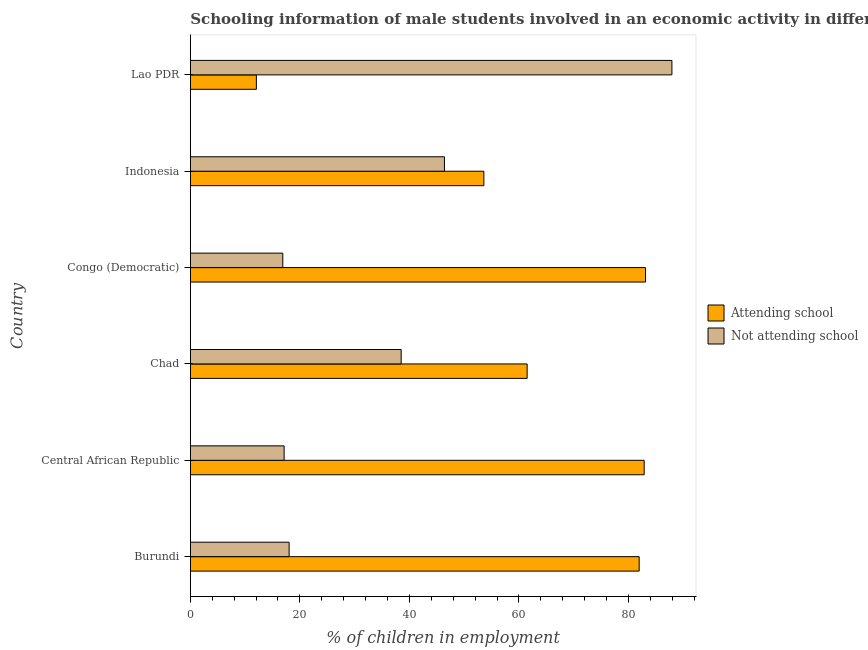How many different coloured bars are there?
Keep it short and to the point. 2. How many groups of bars are there?
Your response must be concise. 6. Are the number of bars per tick equal to the number of legend labels?
Keep it short and to the point. Yes. How many bars are there on the 4th tick from the bottom?
Your answer should be very brief. 2. What is the label of the 6th group of bars from the top?
Make the answer very short. Burundi. What is the percentage of employed males who are not attending school in Congo (Democratic)?
Offer a terse response. 16.89. Across all countries, what is the maximum percentage of employed males who are attending school?
Offer a terse response. 83.11. Across all countries, what is the minimum percentage of employed males who are not attending school?
Ensure brevity in your answer.  16.89. In which country was the percentage of employed males who are attending school maximum?
Your answer should be very brief. Congo (Democratic). In which country was the percentage of employed males who are attending school minimum?
Provide a short and direct response. Lao PDR. What is the total percentage of employed males who are not attending school in the graph?
Your answer should be compact. 224.9. What is the difference between the percentage of employed males who are not attending school in Burundi and that in Lao PDR?
Your answer should be very brief. -69.89. What is the difference between the percentage of employed males who are attending school in Burundi and the percentage of employed males who are not attending school in Indonesia?
Make the answer very short. 35.56. What is the average percentage of employed males who are not attending school per country?
Offer a terse response. 37.48. What is the difference between the percentage of employed males who are attending school and percentage of employed males who are not attending school in Chad?
Your answer should be compact. 23. What is the ratio of the percentage of employed males who are not attending school in Indonesia to that in Lao PDR?
Your response must be concise. 0.53. Is the difference between the percentage of employed males who are not attending school in Burundi and Chad greater than the difference between the percentage of employed males who are attending school in Burundi and Chad?
Your answer should be compact. No. What is the difference between the highest and the second highest percentage of employed males who are not attending school?
Provide a short and direct response. 41.53. What is the difference between the highest and the lowest percentage of employed males who are attending school?
Your answer should be compact. 71.05. In how many countries, is the percentage of employed males who are not attending school greater than the average percentage of employed males who are not attending school taken over all countries?
Give a very brief answer. 3. What does the 1st bar from the top in Burundi represents?
Ensure brevity in your answer.  Not attending school. What does the 2nd bar from the bottom in Burundi represents?
Offer a very short reply. Not attending school. Are all the bars in the graph horizontal?
Offer a terse response. Yes. How many countries are there in the graph?
Give a very brief answer. 6. Are the values on the major ticks of X-axis written in scientific E-notation?
Provide a succinct answer. No. Does the graph contain any zero values?
Ensure brevity in your answer.  No. Does the graph contain grids?
Make the answer very short. No. How are the legend labels stacked?
Provide a short and direct response. Vertical. What is the title of the graph?
Give a very brief answer. Schooling information of male students involved in an economic activity in different countries. What is the label or title of the X-axis?
Your response must be concise. % of children in employment. What is the label or title of the Y-axis?
Ensure brevity in your answer.  Country. What is the % of children in employment in Attending school in Burundi?
Provide a short and direct response. 81.96. What is the % of children in employment of Not attending school in Burundi?
Your answer should be very brief. 18.04. What is the % of children in employment of Attending school in Central African Republic?
Your response must be concise. 82.87. What is the % of children in employment of Not attending school in Central African Republic?
Give a very brief answer. 17.13. What is the % of children in employment of Attending school in Chad?
Keep it short and to the point. 61.5. What is the % of children in employment of Not attending school in Chad?
Your answer should be compact. 38.5. What is the % of children in employment of Attending school in Congo (Democratic)?
Ensure brevity in your answer.  83.11. What is the % of children in employment in Not attending school in Congo (Democratic)?
Ensure brevity in your answer.  16.89. What is the % of children in employment of Attending school in Indonesia?
Give a very brief answer. 53.6. What is the % of children in employment of Not attending school in Indonesia?
Offer a terse response. 46.4. What is the % of children in employment in Attending school in Lao PDR?
Give a very brief answer. 12.07. What is the % of children in employment of Not attending school in Lao PDR?
Provide a succinct answer. 87.93. Across all countries, what is the maximum % of children in employment of Attending school?
Provide a succinct answer. 83.11. Across all countries, what is the maximum % of children in employment in Not attending school?
Give a very brief answer. 87.93. Across all countries, what is the minimum % of children in employment in Attending school?
Your response must be concise. 12.07. Across all countries, what is the minimum % of children in employment in Not attending school?
Provide a succinct answer. 16.89. What is the total % of children in employment in Attending school in the graph?
Offer a terse response. 375.1. What is the total % of children in employment of Not attending school in the graph?
Offer a terse response. 224.9. What is the difference between the % of children in employment of Attending school in Burundi and that in Central African Republic?
Offer a terse response. -0.91. What is the difference between the % of children in employment of Not attending school in Burundi and that in Central African Republic?
Provide a short and direct response. 0.91. What is the difference between the % of children in employment in Attending school in Burundi and that in Chad?
Your answer should be very brief. 20.45. What is the difference between the % of children in employment in Not attending school in Burundi and that in Chad?
Provide a succinct answer. -20.45. What is the difference between the % of children in employment in Attending school in Burundi and that in Congo (Democratic)?
Provide a short and direct response. -1.16. What is the difference between the % of children in employment of Not attending school in Burundi and that in Congo (Democratic)?
Provide a succinct answer. 1.16. What is the difference between the % of children in employment in Attending school in Burundi and that in Indonesia?
Provide a short and direct response. 28.36. What is the difference between the % of children in employment of Not attending school in Burundi and that in Indonesia?
Ensure brevity in your answer.  -28.36. What is the difference between the % of children in employment of Attending school in Burundi and that in Lao PDR?
Make the answer very short. 69.89. What is the difference between the % of children in employment in Not attending school in Burundi and that in Lao PDR?
Make the answer very short. -69.89. What is the difference between the % of children in employment of Attending school in Central African Republic and that in Chad?
Keep it short and to the point. 21.37. What is the difference between the % of children in employment in Not attending school in Central African Republic and that in Chad?
Offer a terse response. -21.37. What is the difference between the % of children in employment in Attending school in Central African Republic and that in Congo (Democratic)?
Your answer should be very brief. -0.24. What is the difference between the % of children in employment in Not attending school in Central African Republic and that in Congo (Democratic)?
Offer a terse response. 0.24. What is the difference between the % of children in employment in Attending school in Central African Republic and that in Indonesia?
Offer a very short reply. 29.27. What is the difference between the % of children in employment of Not attending school in Central African Republic and that in Indonesia?
Make the answer very short. -29.27. What is the difference between the % of children in employment of Attending school in Central African Republic and that in Lao PDR?
Offer a terse response. 70.8. What is the difference between the % of children in employment of Not attending school in Central African Republic and that in Lao PDR?
Make the answer very short. -70.8. What is the difference between the % of children in employment of Attending school in Chad and that in Congo (Democratic)?
Provide a succinct answer. -21.61. What is the difference between the % of children in employment in Not attending school in Chad and that in Congo (Democratic)?
Make the answer very short. 21.61. What is the difference between the % of children in employment in Not attending school in Chad and that in Indonesia?
Offer a terse response. -7.9. What is the difference between the % of children in employment in Attending school in Chad and that in Lao PDR?
Ensure brevity in your answer.  49.43. What is the difference between the % of children in employment of Not attending school in Chad and that in Lao PDR?
Make the answer very short. -49.43. What is the difference between the % of children in employment in Attending school in Congo (Democratic) and that in Indonesia?
Offer a very short reply. 29.51. What is the difference between the % of children in employment in Not attending school in Congo (Democratic) and that in Indonesia?
Provide a short and direct response. -29.51. What is the difference between the % of children in employment in Attending school in Congo (Democratic) and that in Lao PDR?
Keep it short and to the point. 71.05. What is the difference between the % of children in employment in Not attending school in Congo (Democratic) and that in Lao PDR?
Offer a very short reply. -71.05. What is the difference between the % of children in employment in Attending school in Indonesia and that in Lao PDR?
Give a very brief answer. 41.53. What is the difference between the % of children in employment in Not attending school in Indonesia and that in Lao PDR?
Give a very brief answer. -41.53. What is the difference between the % of children in employment in Attending school in Burundi and the % of children in employment in Not attending school in Central African Republic?
Make the answer very short. 64.82. What is the difference between the % of children in employment of Attending school in Burundi and the % of children in employment of Not attending school in Chad?
Keep it short and to the point. 43.45. What is the difference between the % of children in employment of Attending school in Burundi and the % of children in employment of Not attending school in Congo (Democratic)?
Keep it short and to the point. 65.07. What is the difference between the % of children in employment of Attending school in Burundi and the % of children in employment of Not attending school in Indonesia?
Give a very brief answer. 35.55. What is the difference between the % of children in employment of Attending school in Burundi and the % of children in employment of Not attending school in Lao PDR?
Your answer should be compact. -5.98. What is the difference between the % of children in employment in Attending school in Central African Republic and the % of children in employment in Not attending school in Chad?
Offer a very short reply. 44.37. What is the difference between the % of children in employment in Attending school in Central African Republic and the % of children in employment in Not attending school in Congo (Democratic)?
Make the answer very short. 65.98. What is the difference between the % of children in employment in Attending school in Central African Republic and the % of children in employment in Not attending school in Indonesia?
Provide a succinct answer. 36.47. What is the difference between the % of children in employment in Attending school in Central African Republic and the % of children in employment in Not attending school in Lao PDR?
Your response must be concise. -5.07. What is the difference between the % of children in employment of Attending school in Chad and the % of children in employment of Not attending school in Congo (Democratic)?
Give a very brief answer. 44.61. What is the difference between the % of children in employment in Attending school in Chad and the % of children in employment in Not attending school in Indonesia?
Your response must be concise. 15.1. What is the difference between the % of children in employment in Attending school in Chad and the % of children in employment in Not attending school in Lao PDR?
Your answer should be compact. -26.43. What is the difference between the % of children in employment of Attending school in Congo (Democratic) and the % of children in employment of Not attending school in Indonesia?
Ensure brevity in your answer.  36.71. What is the difference between the % of children in employment in Attending school in Congo (Democratic) and the % of children in employment in Not attending school in Lao PDR?
Your response must be concise. -4.82. What is the difference between the % of children in employment of Attending school in Indonesia and the % of children in employment of Not attending school in Lao PDR?
Provide a succinct answer. -34.33. What is the average % of children in employment of Attending school per country?
Make the answer very short. 62.52. What is the average % of children in employment in Not attending school per country?
Provide a short and direct response. 37.48. What is the difference between the % of children in employment of Attending school and % of children in employment of Not attending school in Burundi?
Your answer should be very brief. 63.91. What is the difference between the % of children in employment of Attending school and % of children in employment of Not attending school in Central African Republic?
Offer a very short reply. 65.74. What is the difference between the % of children in employment in Attending school and % of children in employment in Not attending school in Chad?
Offer a terse response. 23. What is the difference between the % of children in employment in Attending school and % of children in employment in Not attending school in Congo (Democratic)?
Your answer should be compact. 66.23. What is the difference between the % of children in employment in Attending school and % of children in employment in Not attending school in Indonesia?
Give a very brief answer. 7.2. What is the difference between the % of children in employment of Attending school and % of children in employment of Not attending school in Lao PDR?
Make the answer very short. -75.87. What is the ratio of the % of children in employment in Attending school in Burundi to that in Central African Republic?
Your response must be concise. 0.99. What is the ratio of the % of children in employment of Not attending school in Burundi to that in Central African Republic?
Offer a very short reply. 1.05. What is the ratio of the % of children in employment of Attending school in Burundi to that in Chad?
Make the answer very short. 1.33. What is the ratio of the % of children in employment of Not attending school in Burundi to that in Chad?
Offer a terse response. 0.47. What is the ratio of the % of children in employment of Attending school in Burundi to that in Congo (Democratic)?
Make the answer very short. 0.99. What is the ratio of the % of children in employment of Not attending school in Burundi to that in Congo (Democratic)?
Give a very brief answer. 1.07. What is the ratio of the % of children in employment in Attending school in Burundi to that in Indonesia?
Offer a very short reply. 1.53. What is the ratio of the % of children in employment in Not attending school in Burundi to that in Indonesia?
Make the answer very short. 0.39. What is the ratio of the % of children in employment in Attending school in Burundi to that in Lao PDR?
Provide a short and direct response. 6.79. What is the ratio of the % of children in employment of Not attending school in Burundi to that in Lao PDR?
Provide a short and direct response. 0.21. What is the ratio of the % of children in employment in Attending school in Central African Republic to that in Chad?
Your answer should be compact. 1.35. What is the ratio of the % of children in employment in Not attending school in Central African Republic to that in Chad?
Ensure brevity in your answer.  0.45. What is the ratio of the % of children in employment in Not attending school in Central African Republic to that in Congo (Democratic)?
Provide a short and direct response. 1.01. What is the ratio of the % of children in employment in Attending school in Central African Republic to that in Indonesia?
Offer a very short reply. 1.55. What is the ratio of the % of children in employment in Not attending school in Central African Republic to that in Indonesia?
Your answer should be very brief. 0.37. What is the ratio of the % of children in employment in Attending school in Central African Republic to that in Lao PDR?
Provide a short and direct response. 6.87. What is the ratio of the % of children in employment in Not attending school in Central African Republic to that in Lao PDR?
Your response must be concise. 0.19. What is the ratio of the % of children in employment of Attending school in Chad to that in Congo (Democratic)?
Give a very brief answer. 0.74. What is the ratio of the % of children in employment in Not attending school in Chad to that in Congo (Democratic)?
Your answer should be compact. 2.28. What is the ratio of the % of children in employment of Attending school in Chad to that in Indonesia?
Your answer should be very brief. 1.15. What is the ratio of the % of children in employment of Not attending school in Chad to that in Indonesia?
Provide a succinct answer. 0.83. What is the ratio of the % of children in employment of Attending school in Chad to that in Lao PDR?
Give a very brief answer. 5.1. What is the ratio of the % of children in employment in Not attending school in Chad to that in Lao PDR?
Provide a succinct answer. 0.44. What is the ratio of the % of children in employment of Attending school in Congo (Democratic) to that in Indonesia?
Provide a short and direct response. 1.55. What is the ratio of the % of children in employment in Not attending school in Congo (Democratic) to that in Indonesia?
Your answer should be very brief. 0.36. What is the ratio of the % of children in employment in Attending school in Congo (Democratic) to that in Lao PDR?
Your answer should be very brief. 6.89. What is the ratio of the % of children in employment of Not attending school in Congo (Democratic) to that in Lao PDR?
Ensure brevity in your answer.  0.19. What is the ratio of the % of children in employment of Attending school in Indonesia to that in Lao PDR?
Give a very brief answer. 4.44. What is the ratio of the % of children in employment of Not attending school in Indonesia to that in Lao PDR?
Make the answer very short. 0.53. What is the difference between the highest and the second highest % of children in employment of Attending school?
Your response must be concise. 0.24. What is the difference between the highest and the second highest % of children in employment of Not attending school?
Provide a short and direct response. 41.53. What is the difference between the highest and the lowest % of children in employment in Attending school?
Provide a short and direct response. 71.05. What is the difference between the highest and the lowest % of children in employment in Not attending school?
Provide a short and direct response. 71.05. 